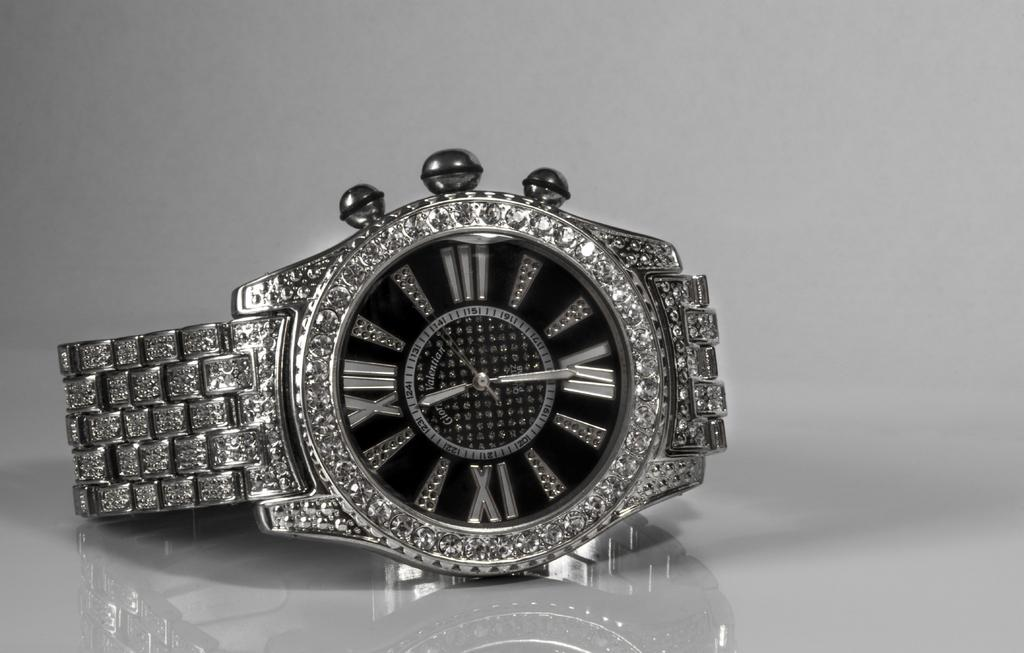What object can be seen in the image? There is a watch in the image. What type of patch can be seen on the watch in the image? There is no patch visible on the watch in the image. What kind of waves can be seen in the background of the image? There is no background or waves present in the image; it only features a watch. 